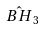Convert formula to latex. <formula><loc_0><loc_0><loc_500><loc_500>\hat { B H } _ { 3 }</formula> 